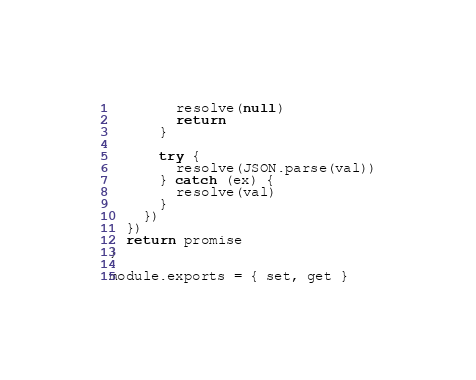Convert code to text. <code><loc_0><loc_0><loc_500><loc_500><_JavaScript_>        resolve(null)
        return
      }

      try {
        resolve(JSON.parse(val))
      } catch (ex) {
        resolve(val)
      }
    })
  })
  return promise
}

module.exports = { set, get }
</code> 